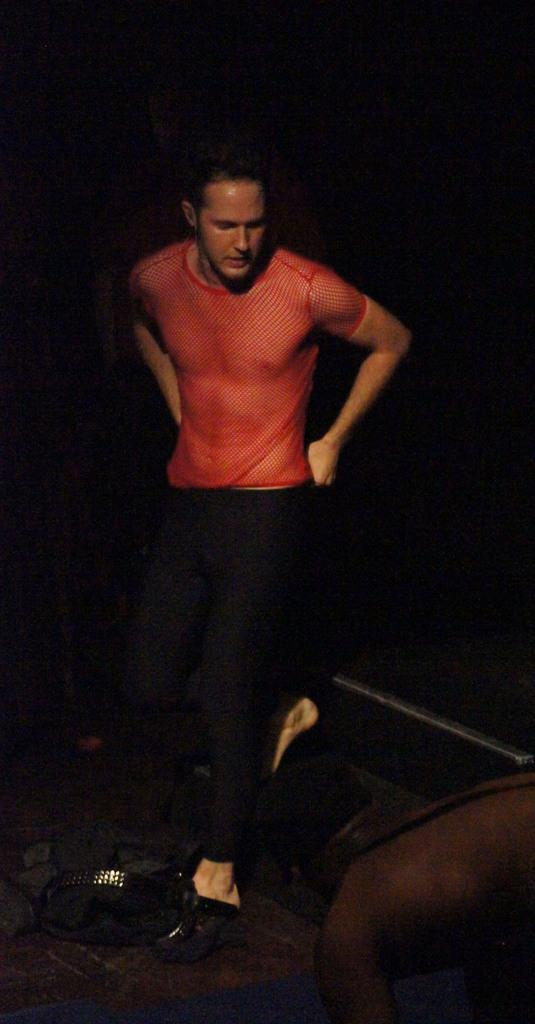What is the main subject of the image? There is a man standing in the center of the image. Can you describe any objects in the scene? There are some objects in the scene, but their specific details are not mentioned in the facts. How would you describe the overall lighting or color of the image? The background of the image is dark. What type of soup is being served in the image? There is no soup present in the image. How did the earthquake affect the man in the image? There is no mention of an earthquake in the image or the facts provided. 